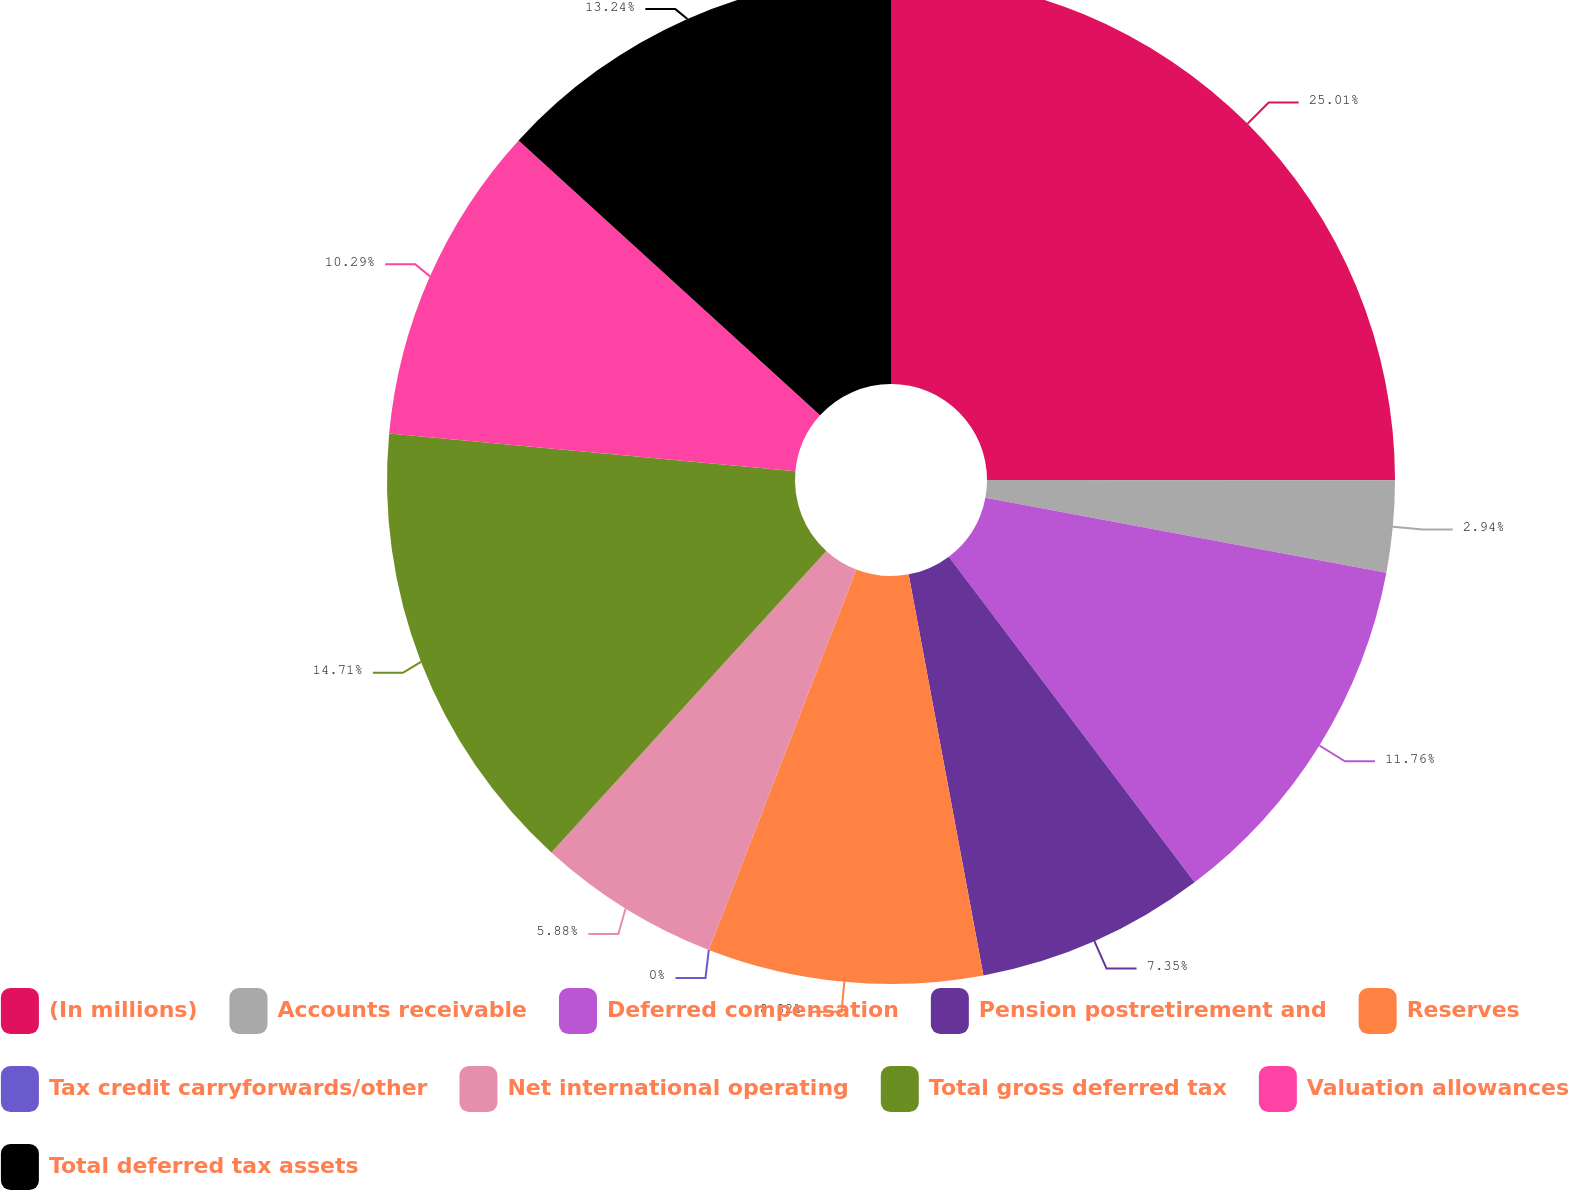<chart> <loc_0><loc_0><loc_500><loc_500><pie_chart><fcel>(In millions)<fcel>Accounts receivable<fcel>Deferred compensation<fcel>Pension postretirement and<fcel>Reserves<fcel>Tax credit carryforwards/other<fcel>Net international operating<fcel>Total gross deferred tax<fcel>Valuation allowances<fcel>Total deferred tax assets<nl><fcel>25.0%<fcel>2.94%<fcel>11.76%<fcel>7.35%<fcel>8.82%<fcel>0.0%<fcel>5.88%<fcel>14.7%<fcel>10.29%<fcel>13.23%<nl></chart> 